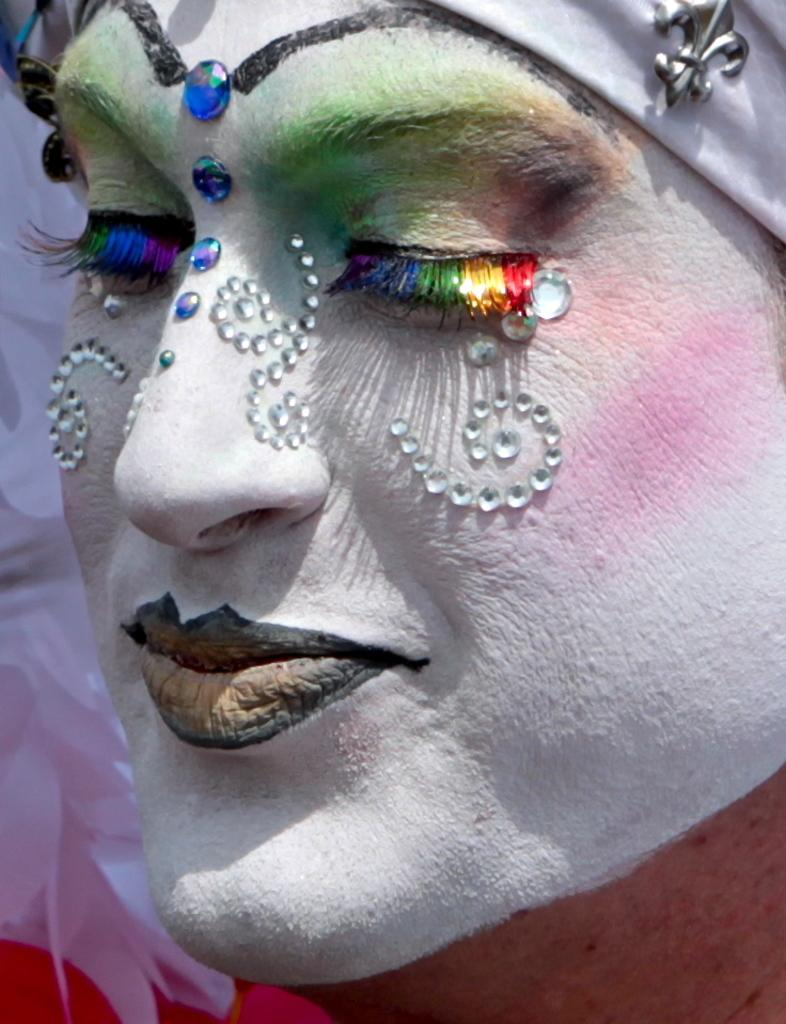What is the main subject of the image? There is a person in the image. Can you describe the person's appearance? The person has white paint on their face. What else can be seen in the image besides the person? There are other objects in the image. What level of expertise does the person have in zinc production? There is no information about zinc production or the person's level of expertise in the image. 